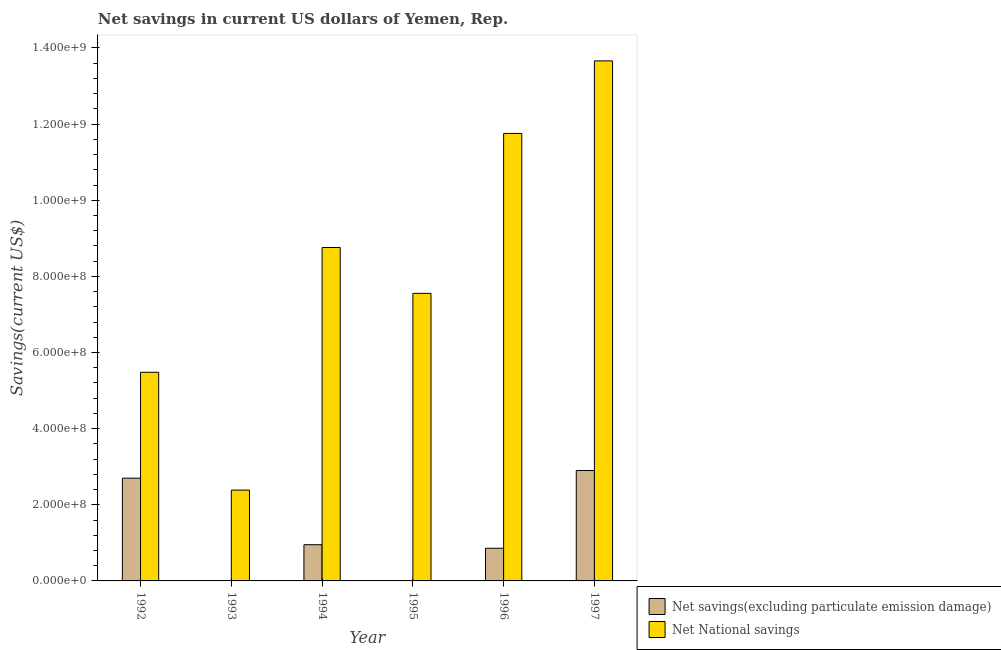How many different coloured bars are there?
Give a very brief answer. 2. Are the number of bars per tick equal to the number of legend labels?
Make the answer very short. No. Are the number of bars on each tick of the X-axis equal?
Your response must be concise. No. How many bars are there on the 2nd tick from the left?
Your answer should be compact. 1. How many bars are there on the 6th tick from the right?
Provide a succinct answer. 2. What is the net national savings in 1992?
Provide a short and direct response. 5.48e+08. Across all years, what is the maximum net national savings?
Offer a terse response. 1.37e+09. Across all years, what is the minimum net national savings?
Make the answer very short. 2.39e+08. In which year was the net savings(excluding particulate emission damage) maximum?
Make the answer very short. 1997. What is the total net savings(excluding particulate emission damage) in the graph?
Your answer should be very brief. 7.41e+08. What is the difference between the net savings(excluding particulate emission damage) in 1992 and that in 1997?
Your response must be concise. -2.01e+07. What is the difference between the net national savings in 1995 and the net savings(excluding particulate emission damage) in 1993?
Your answer should be compact. 5.17e+08. What is the average net national savings per year?
Give a very brief answer. 8.27e+08. What is the ratio of the net national savings in 1996 to that in 1997?
Offer a terse response. 0.86. Is the net savings(excluding particulate emission damage) in 1996 less than that in 1997?
Your answer should be compact. Yes. Is the difference between the net national savings in 1992 and 1994 greater than the difference between the net savings(excluding particulate emission damage) in 1992 and 1994?
Your response must be concise. No. What is the difference between the highest and the second highest net savings(excluding particulate emission damage)?
Your answer should be compact. 2.01e+07. What is the difference between the highest and the lowest net savings(excluding particulate emission damage)?
Make the answer very short. 2.90e+08. In how many years, is the net savings(excluding particulate emission damage) greater than the average net savings(excluding particulate emission damage) taken over all years?
Make the answer very short. 2. Are all the bars in the graph horizontal?
Make the answer very short. No. What is the difference between two consecutive major ticks on the Y-axis?
Keep it short and to the point. 2.00e+08. Are the values on the major ticks of Y-axis written in scientific E-notation?
Ensure brevity in your answer.  Yes. Does the graph contain grids?
Your answer should be compact. No. What is the title of the graph?
Your answer should be compact. Net savings in current US dollars of Yemen, Rep. Does "From Government" appear as one of the legend labels in the graph?
Your answer should be compact. No. What is the label or title of the Y-axis?
Make the answer very short. Savings(current US$). What is the Savings(current US$) of Net savings(excluding particulate emission damage) in 1992?
Give a very brief answer. 2.70e+08. What is the Savings(current US$) of Net National savings in 1992?
Provide a succinct answer. 5.48e+08. What is the Savings(current US$) in Net National savings in 1993?
Offer a very short reply. 2.39e+08. What is the Savings(current US$) of Net savings(excluding particulate emission damage) in 1994?
Offer a very short reply. 9.51e+07. What is the Savings(current US$) in Net National savings in 1994?
Provide a succinct answer. 8.76e+08. What is the Savings(current US$) of Net National savings in 1995?
Offer a terse response. 7.55e+08. What is the Savings(current US$) in Net savings(excluding particulate emission damage) in 1996?
Provide a short and direct response. 8.58e+07. What is the Savings(current US$) in Net National savings in 1996?
Give a very brief answer. 1.18e+09. What is the Savings(current US$) in Net savings(excluding particulate emission damage) in 1997?
Offer a terse response. 2.90e+08. What is the Savings(current US$) of Net National savings in 1997?
Give a very brief answer. 1.37e+09. Across all years, what is the maximum Savings(current US$) in Net savings(excluding particulate emission damage)?
Give a very brief answer. 2.90e+08. Across all years, what is the maximum Savings(current US$) of Net National savings?
Give a very brief answer. 1.37e+09. Across all years, what is the minimum Savings(current US$) of Net savings(excluding particulate emission damage)?
Offer a terse response. 0. Across all years, what is the minimum Savings(current US$) of Net National savings?
Ensure brevity in your answer.  2.39e+08. What is the total Savings(current US$) in Net savings(excluding particulate emission damage) in the graph?
Your answer should be compact. 7.41e+08. What is the total Savings(current US$) in Net National savings in the graph?
Your answer should be compact. 4.96e+09. What is the difference between the Savings(current US$) of Net National savings in 1992 and that in 1993?
Offer a terse response. 3.09e+08. What is the difference between the Savings(current US$) in Net savings(excluding particulate emission damage) in 1992 and that in 1994?
Your answer should be very brief. 1.75e+08. What is the difference between the Savings(current US$) in Net National savings in 1992 and that in 1994?
Your answer should be very brief. -3.28e+08. What is the difference between the Savings(current US$) in Net National savings in 1992 and that in 1995?
Offer a very short reply. -2.07e+08. What is the difference between the Savings(current US$) of Net savings(excluding particulate emission damage) in 1992 and that in 1996?
Provide a succinct answer. 1.84e+08. What is the difference between the Savings(current US$) of Net National savings in 1992 and that in 1996?
Make the answer very short. -6.27e+08. What is the difference between the Savings(current US$) in Net savings(excluding particulate emission damage) in 1992 and that in 1997?
Your response must be concise. -2.01e+07. What is the difference between the Savings(current US$) of Net National savings in 1992 and that in 1997?
Provide a short and direct response. -8.18e+08. What is the difference between the Savings(current US$) in Net National savings in 1993 and that in 1994?
Give a very brief answer. -6.37e+08. What is the difference between the Savings(current US$) of Net National savings in 1993 and that in 1995?
Offer a very short reply. -5.17e+08. What is the difference between the Savings(current US$) in Net National savings in 1993 and that in 1996?
Your answer should be very brief. -9.37e+08. What is the difference between the Savings(current US$) of Net National savings in 1993 and that in 1997?
Ensure brevity in your answer.  -1.13e+09. What is the difference between the Savings(current US$) in Net National savings in 1994 and that in 1995?
Offer a very short reply. 1.21e+08. What is the difference between the Savings(current US$) in Net savings(excluding particulate emission damage) in 1994 and that in 1996?
Give a very brief answer. 9.27e+06. What is the difference between the Savings(current US$) of Net National savings in 1994 and that in 1996?
Keep it short and to the point. -3.00e+08. What is the difference between the Savings(current US$) of Net savings(excluding particulate emission damage) in 1994 and that in 1997?
Make the answer very short. -1.95e+08. What is the difference between the Savings(current US$) of Net National savings in 1994 and that in 1997?
Your response must be concise. -4.90e+08. What is the difference between the Savings(current US$) of Net National savings in 1995 and that in 1996?
Give a very brief answer. -4.20e+08. What is the difference between the Savings(current US$) in Net National savings in 1995 and that in 1997?
Your answer should be compact. -6.11e+08. What is the difference between the Savings(current US$) of Net savings(excluding particulate emission damage) in 1996 and that in 1997?
Provide a short and direct response. -2.04e+08. What is the difference between the Savings(current US$) in Net National savings in 1996 and that in 1997?
Your response must be concise. -1.91e+08. What is the difference between the Savings(current US$) in Net savings(excluding particulate emission damage) in 1992 and the Savings(current US$) in Net National savings in 1993?
Provide a succinct answer. 3.13e+07. What is the difference between the Savings(current US$) of Net savings(excluding particulate emission damage) in 1992 and the Savings(current US$) of Net National savings in 1994?
Make the answer very short. -6.06e+08. What is the difference between the Savings(current US$) of Net savings(excluding particulate emission damage) in 1992 and the Savings(current US$) of Net National savings in 1995?
Make the answer very short. -4.85e+08. What is the difference between the Savings(current US$) in Net savings(excluding particulate emission damage) in 1992 and the Savings(current US$) in Net National savings in 1996?
Provide a succinct answer. -9.06e+08. What is the difference between the Savings(current US$) of Net savings(excluding particulate emission damage) in 1992 and the Savings(current US$) of Net National savings in 1997?
Provide a short and direct response. -1.10e+09. What is the difference between the Savings(current US$) in Net savings(excluding particulate emission damage) in 1994 and the Savings(current US$) in Net National savings in 1995?
Your answer should be very brief. -6.60e+08. What is the difference between the Savings(current US$) of Net savings(excluding particulate emission damage) in 1994 and the Savings(current US$) of Net National savings in 1996?
Give a very brief answer. -1.08e+09. What is the difference between the Savings(current US$) of Net savings(excluding particulate emission damage) in 1994 and the Savings(current US$) of Net National savings in 1997?
Offer a terse response. -1.27e+09. What is the difference between the Savings(current US$) of Net savings(excluding particulate emission damage) in 1996 and the Savings(current US$) of Net National savings in 1997?
Your answer should be very brief. -1.28e+09. What is the average Savings(current US$) of Net savings(excluding particulate emission damage) per year?
Provide a short and direct response. 1.23e+08. What is the average Savings(current US$) in Net National savings per year?
Provide a succinct answer. 8.27e+08. In the year 1992, what is the difference between the Savings(current US$) in Net savings(excluding particulate emission damage) and Savings(current US$) in Net National savings?
Offer a very short reply. -2.78e+08. In the year 1994, what is the difference between the Savings(current US$) in Net savings(excluding particulate emission damage) and Savings(current US$) in Net National savings?
Your answer should be compact. -7.81e+08. In the year 1996, what is the difference between the Savings(current US$) of Net savings(excluding particulate emission damage) and Savings(current US$) of Net National savings?
Your answer should be compact. -1.09e+09. In the year 1997, what is the difference between the Savings(current US$) in Net savings(excluding particulate emission damage) and Savings(current US$) in Net National savings?
Provide a short and direct response. -1.08e+09. What is the ratio of the Savings(current US$) in Net National savings in 1992 to that in 1993?
Make the answer very short. 2.3. What is the ratio of the Savings(current US$) of Net savings(excluding particulate emission damage) in 1992 to that in 1994?
Offer a terse response. 2.84. What is the ratio of the Savings(current US$) in Net National savings in 1992 to that in 1994?
Offer a very short reply. 0.63. What is the ratio of the Savings(current US$) in Net National savings in 1992 to that in 1995?
Provide a succinct answer. 0.73. What is the ratio of the Savings(current US$) in Net savings(excluding particulate emission damage) in 1992 to that in 1996?
Your response must be concise. 3.15. What is the ratio of the Savings(current US$) in Net National savings in 1992 to that in 1996?
Your answer should be compact. 0.47. What is the ratio of the Savings(current US$) of Net savings(excluding particulate emission damage) in 1992 to that in 1997?
Make the answer very short. 0.93. What is the ratio of the Savings(current US$) of Net National savings in 1992 to that in 1997?
Offer a very short reply. 0.4. What is the ratio of the Savings(current US$) in Net National savings in 1993 to that in 1994?
Give a very brief answer. 0.27. What is the ratio of the Savings(current US$) in Net National savings in 1993 to that in 1995?
Offer a terse response. 0.32. What is the ratio of the Savings(current US$) of Net National savings in 1993 to that in 1996?
Offer a very short reply. 0.2. What is the ratio of the Savings(current US$) in Net National savings in 1993 to that in 1997?
Ensure brevity in your answer.  0.17. What is the ratio of the Savings(current US$) of Net National savings in 1994 to that in 1995?
Ensure brevity in your answer.  1.16. What is the ratio of the Savings(current US$) in Net savings(excluding particulate emission damage) in 1994 to that in 1996?
Offer a terse response. 1.11. What is the ratio of the Savings(current US$) in Net National savings in 1994 to that in 1996?
Your answer should be compact. 0.75. What is the ratio of the Savings(current US$) in Net savings(excluding particulate emission damage) in 1994 to that in 1997?
Provide a short and direct response. 0.33. What is the ratio of the Savings(current US$) in Net National savings in 1994 to that in 1997?
Make the answer very short. 0.64. What is the ratio of the Savings(current US$) of Net National savings in 1995 to that in 1996?
Offer a very short reply. 0.64. What is the ratio of the Savings(current US$) in Net National savings in 1995 to that in 1997?
Your response must be concise. 0.55. What is the ratio of the Savings(current US$) in Net savings(excluding particulate emission damage) in 1996 to that in 1997?
Ensure brevity in your answer.  0.3. What is the ratio of the Savings(current US$) of Net National savings in 1996 to that in 1997?
Give a very brief answer. 0.86. What is the difference between the highest and the second highest Savings(current US$) in Net savings(excluding particulate emission damage)?
Give a very brief answer. 2.01e+07. What is the difference between the highest and the second highest Savings(current US$) of Net National savings?
Offer a terse response. 1.91e+08. What is the difference between the highest and the lowest Savings(current US$) in Net savings(excluding particulate emission damage)?
Your answer should be very brief. 2.90e+08. What is the difference between the highest and the lowest Savings(current US$) in Net National savings?
Your answer should be compact. 1.13e+09. 